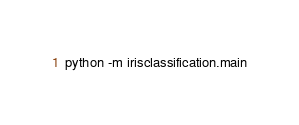<code> <loc_0><loc_0><loc_500><loc_500><_Bash_>
python -m irisclassification.main

</code> 